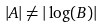Convert formula to latex. <formula><loc_0><loc_0><loc_500><loc_500>| A | \neq | \log ( B ) |</formula> 